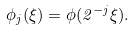Convert formula to latex. <formula><loc_0><loc_0><loc_500><loc_500>\phi _ { j } ( \xi ) = \phi ( 2 ^ { - j } \xi ) .</formula> 